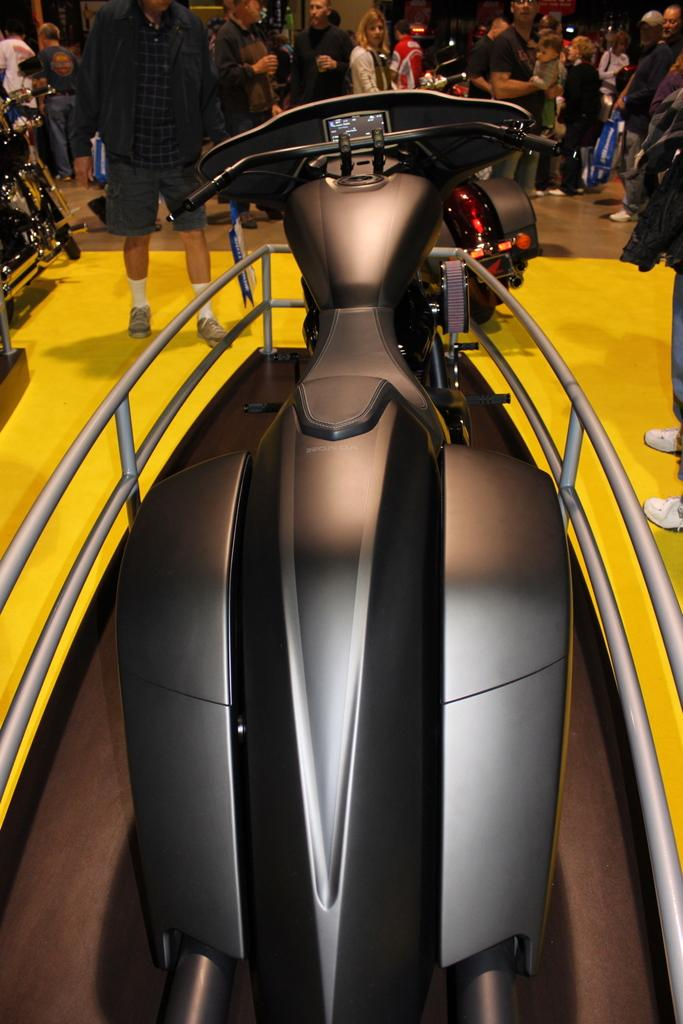What is the main object in the image? There is a bike in the image. Where is the bike located? The bike is in an expo. Can you describe the surroundings in the image? There are people in the background of the image. What type of pail is being used for teaching in the image? There is no pail or teaching activity present in the image. What flag is being waved by the people in the image? There are no flags visible in the image. 